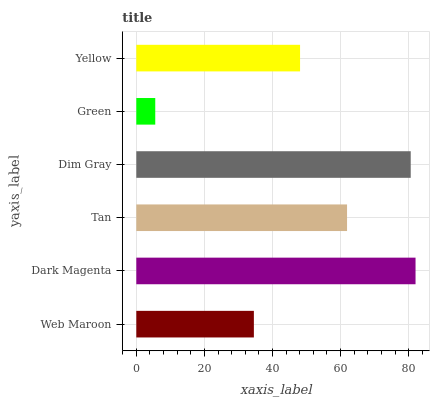Is Green the minimum?
Answer yes or no. Yes. Is Dark Magenta the maximum?
Answer yes or no. Yes. Is Tan the minimum?
Answer yes or no. No. Is Tan the maximum?
Answer yes or no. No. Is Dark Magenta greater than Tan?
Answer yes or no. Yes. Is Tan less than Dark Magenta?
Answer yes or no. Yes. Is Tan greater than Dark Magenta?
Answer yes or no. No. Is Dark Magenta less than Tan?
Answer yes or no. No. Is Tan the high median?
Answer yes or no. Yes. Is Yellow the low median?
Answer yes or no. Yes. Is Dark Magenta the high median?
Answer yes or no. No. Is Green the low median?
Answer yes or no. No. 